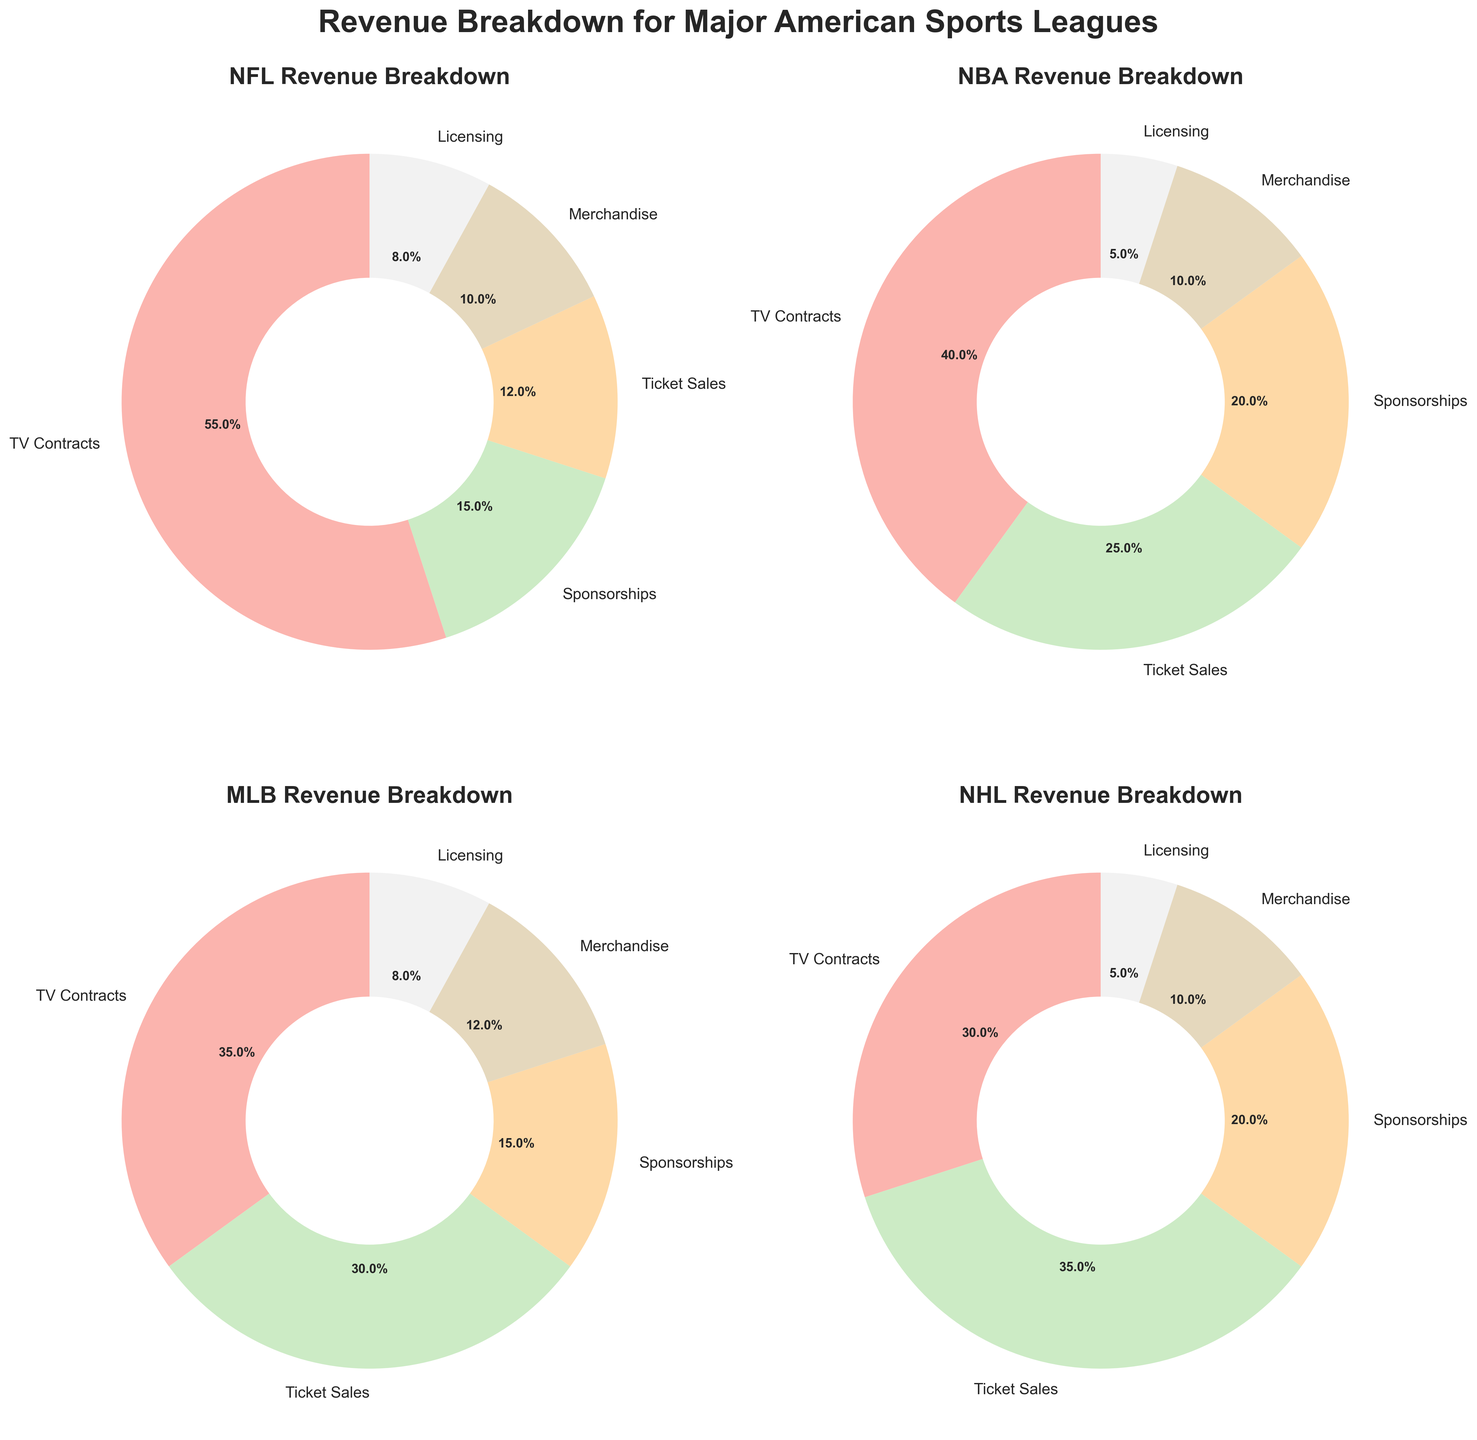What is the most significant revenue source for the NFL? The largest wedge in the NFL’s pie chart is labeled "TV Contracts," which accounts for more than half of the pie.
Answer: TV Contracts Which league has the highest percentage of revenue from ticket sales? By comparing the sizes of the wedges for ticket sales across all four pie charts, the NHL has the largest wedge for ticket sales at 35%.
Answer: NHL What is the combined revenue percentage from sponsorships and merchandise for the NBA? For the NBA, the sponsorships are 20% and merchandise is 10%. Adding these together, 20% + 10% = 30%.
Answer: 30% Does any revenue source contribute exactly 8% for multiple leagues? Analyzing the pie charts, NFL and MLB both have licensing revenue that contributes exactly 8%.
Answer: Yes Compare the revenue percentages from merchandise between MLB and NHL. Which one is higher? The pie chart for MLB shows merchandise revenue at 12%, while the NHL's pie chart shows it at 10%. A comparison shows that MLB’s percentage is higher.
Answer: MLB What is the total revenue percentage from non-TV sources for the NHL? The NHL has the following non-TV sources: Ticket Sales (35%), Sponsorships (20%), Merchandise (10%), and Licensing (5%). Summing these percentages gives 35% + 20% + 10% + 5% = 70%.
Answer: 70% Which league has the smallest slice for licensing revenue? The smallest wedge for licensing revenue across all leagues is seen in the NBA, where it is 5%.
Answer: NBA What is the difference in revenue percentage from TV contracts between NFL and MLB? NFL's revenue from TV contracts is 55%, and MLB's is 35%. The difference is 55% - 35% = 20%.
Answer: 20% What is the average percentage contribution from sponsorships across all leagues? Sponsorship percentages are NFL (15%), NBA (20%), MLB (15%), and NHL (20%). The average is calculated as (15% + 20% + 15% + 20%) / 4 = 70% / 4 = 17.5%.
Answer: 17.5% How does the proportion of revenue from merchandise compare between NFL and NBA? The pie chart for both NFL and NBA shows merchandise revenue at 10%. Hence, they have an equal percentage for merchandise revenue.
Answer: Equal 